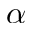Convert formula to latex. <formula><loc_0><loc_0><loc_500><loc_500>\alpha</formula> 